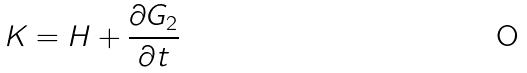Convert formula to latex. <formula><loc_0><loc_0><loc_500><loc_500>K = H + \frac { \partial G _ { 2 } } { \partial t }</formula> 